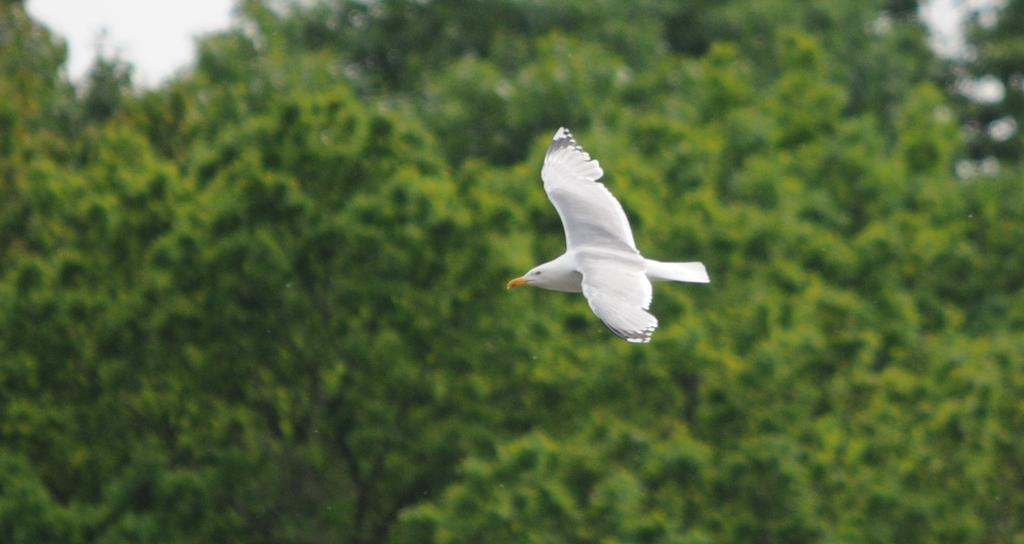What type of animal can be seen in the image? There is a white-colored bird in the image. What is the bird doing in the image? The bird is flying in the air. What can be seen in the background of the image? There are trees and leaves visible in the image. What part of the sky is visible in the image? The sky is visible in the top left of the image. How many children are playing with the bird in the image? There are no children present in the image; it only features a white-colored bird flying in the air. 